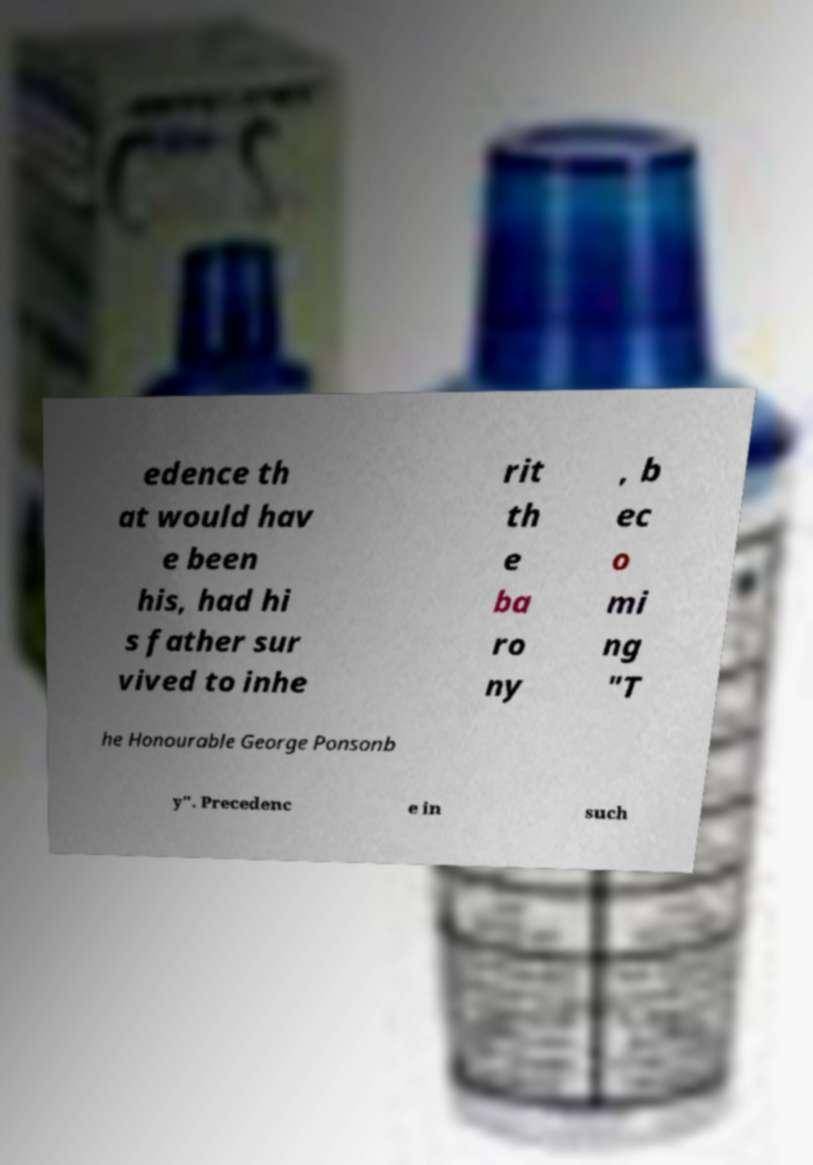Could you assist in decoding the text presented in this image and type it out clearly? edence th at would hav e been his, had hi s father sur vived to inhe rit th e ba ro ny , b ec o mi ng "T he Honourable George Ponsonb y". Precedenc e in such 